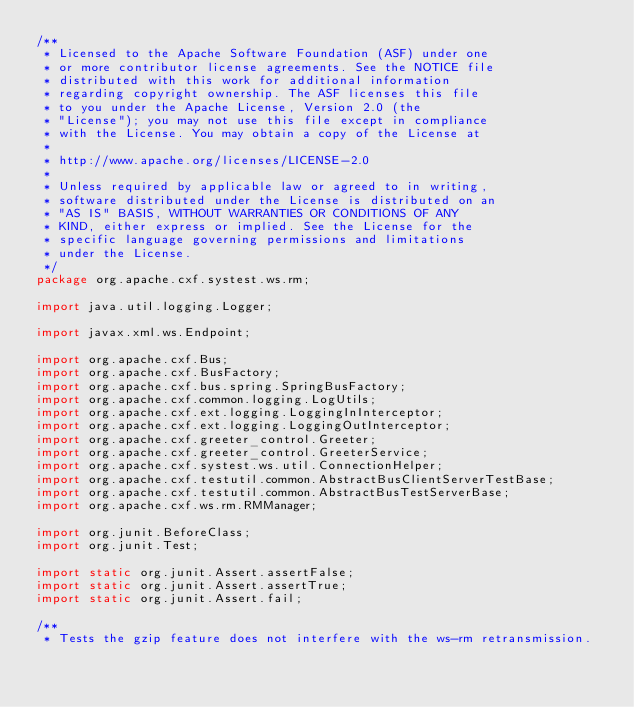<code> <loc_0><loc_0><loc_500><loc_500><_Java_>/**
 * Licensed to the Apache Software Foundation (ASF) under one
 * or more contributor license agreements. See the NOTICE file
 * distributed with this work for additional information
 * regarding copyright ownership. The ASF licenses this file
 * to you under the Apache License, Version 2.0 (the
 * "License"); you may not use this file except in compliance
 * with the License. You may obtain a copy of the License at
 *
 * http://www.apache.org/licenses/LICENSE-2.0
 *
 * Unless required by applicable law or agreed to in writing,
 * software distributed under the License is distributed on an
 * "AS IS" BASIS, WITHOUT WARRANTIES OR CONDITIONS OF ANY
 * KIND, either express or implied. See the License for the
 * specific language governing permissions and limitations
 * under the License.
 */
package org.apache.cxf.systest.ws.rm;

import java.util.logging.Logger;

import javax.xml.ws.Endpoint;

import org.apache.cxf.Bus;
import org.apache.cxf.BusFactory;
import org.apache.cxf.bus.spring.SpringBusFactory;
import org.apache.cxf.common.logging.LogUtils;
import org.apache.cxf.ext.logging.LoggingInInterceptor;
import org.apache.cxf.ext.logging.LoggingOutInterceptor;
import org.apache.cxf.greeter_control.Greeter;
import org.apache.cxf.greeter_control.GreeterService;
import org.apache.cxf.systest.ws.util.ConnectionHelper;
import org.apache.cxf.testutil.common.AbstractBusClientServerTestBase;
import org.apache.cxf.testutil.common.AbstractBusTestServerBase;
import org.apache.cxf.ws.rm.RMManager;

import org.junit.BeforeClass;
import org.junit.Test;

import static org.junit.Assert.assertFalse;
import static org.junit.Assert.assertTrue;
import static org.junit.Assert.fail;

/**
 * Tests the gzip feature does not interfere with the ws-rm retransmission.</code> 